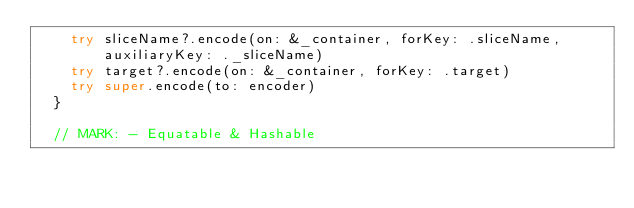Convert code to text. <code><loc_0><loc_0><loc_500><loc_500><_Swift_>		try sliceName?.encode(on: &_container, forKey: .sliceName, auxiliaryKey: ._sliceName)
		try target?.encode(on: &_container, forKey: .target)
		try super.encode(to: encoder)
	}
	
	// MARK: - Equatable & Hashable
	</code> 